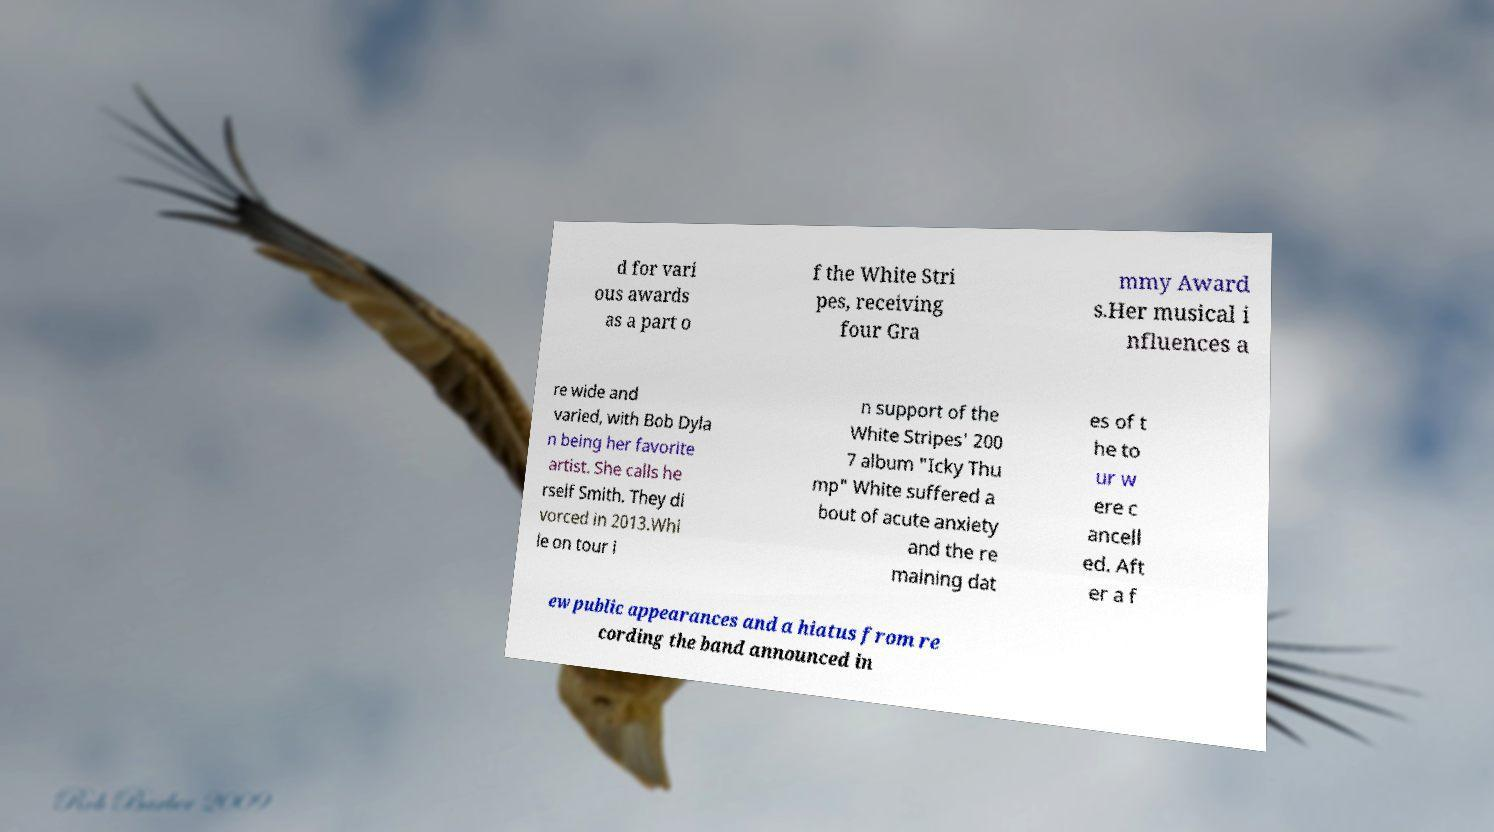Could you assist in decoding the text presented in this image and type it out clearly? d for vari ous awards as a part o f the White Stri pes, receiving four Gra mmy Award s.Her musical i nfluences a re wide and varied, with Bob Dyla n being her favorite artist. She calls he rself Smith. They di vorced in 2013.Whi le on tour i n support of the White Stripes' 200 7 album "Icky Thu mp" White suffered a bout of acute anxiety and the re maining dat es of t he to ur w ere c ancell ed. Aft er a f ew public appearances and a hiatus from re cording the band announced in 